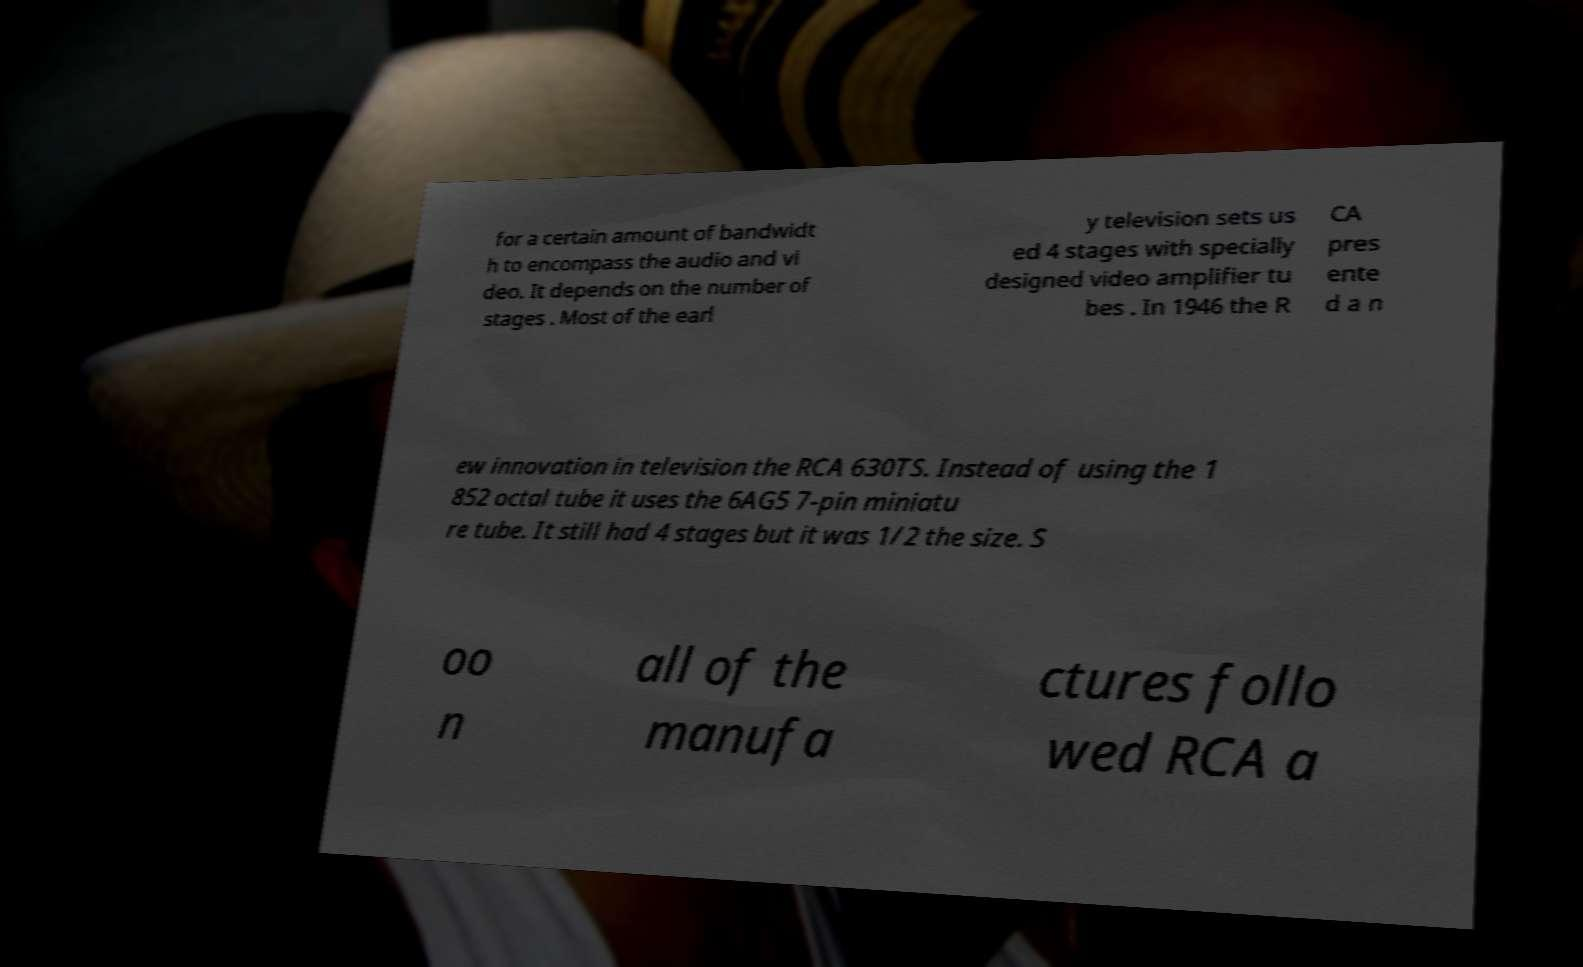Please identify and transcribe the text found in this image. for a certain amount of bandwidt h to encompass the audio and vi deo. It depends on the number of stages . Most of the earl y television sets us ed 4 stages with specially designed video amplifier tu bes . In 1946 the R CA pres ente d a n ew innovation in television the RCA 630TS. Instead of using the 1 852 octal tube it uses the 6AG5 7-pin miniatu re tube. It still had 4 stages but it was 1/2 the size. S oo n all of the manufa ctures follo wed RCA a 